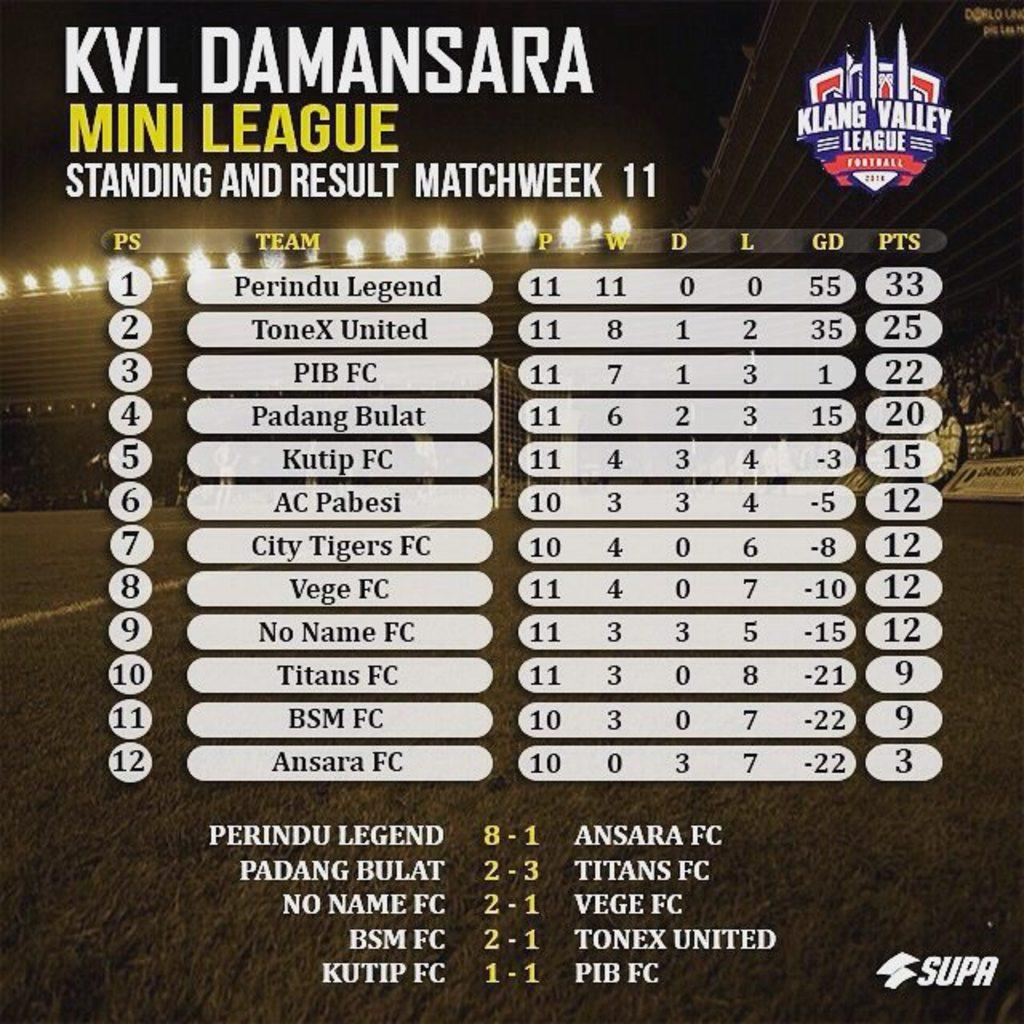<image>
Describe the image concisely. A standings board for the KVL Damansara mini league shows 12 teams. 